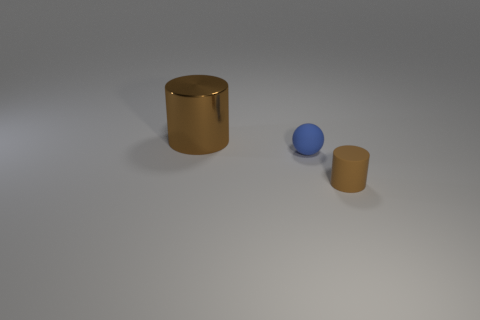Is there any other thing that is the same size as the brown shiny cylinder?
Give a very brief answer. No. What is the color of the object that is to the left of the brown matte cylinder and in front of the big cylinder?
Keep it short and to the point. Blue. The other object that is the same shape as the small brown thing is what size?
Your answer should be very brief. Large. What is the color of the big shiny thing that is the same shape as the small brown rubber object?
Your answer should be very brief. Brown. Is the blue rubber thing the same shape as the large brown shiny thing?
Give a very brief answer. No. How many balls are large brown metal things or blue matte things?
Your answer should be compact. 1. What color is the thing that is the same material as the blue ball?
Your response must be concise. Brown. Is the size of the blue thing that is behind the brown rubber object the same as the tiny brown matte cylinder?
Offer a terse response. Yes. Are the small blue ball and the brown cylinder that is right of the blue rubber ball made of the same material?
Keep it short and to the point. Yes. What color is the object in front of the small blue rubber sphere?
Offer a very short reply. Brown. 